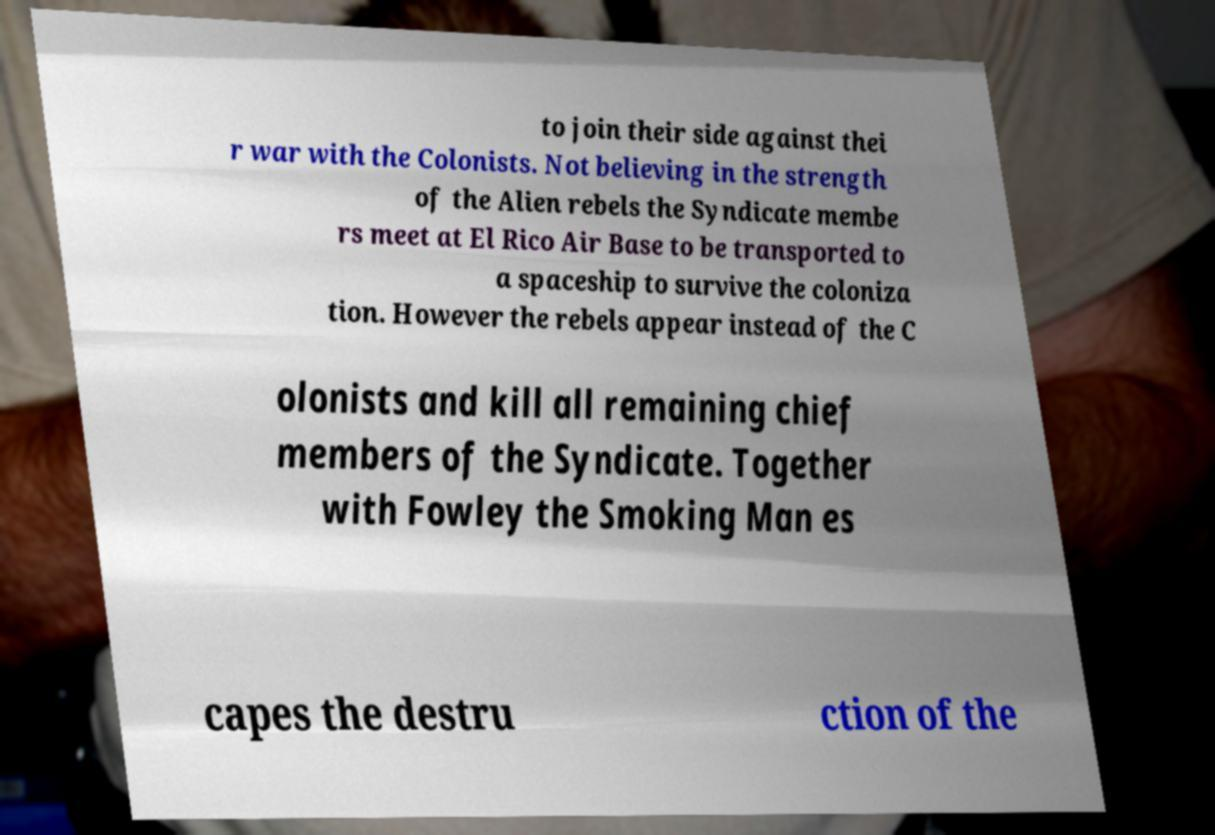I need the written content from this picture converted into text. Can you do that? to join their side against thei r war with the Colonists. Not believing in the strength of the Alien rebels the Syndicate membe rs meet at El Rico Air Base to be transported to a spaceship to survive the coloniza tion. However the rebels appear instead of the C olonists and kill all remaining chief members of the Syndicate. Together with Fowley the Smoking Man es capes the destru ction of the 